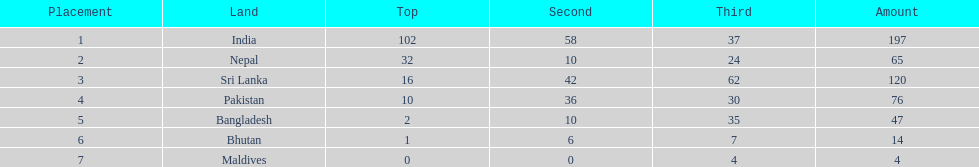How many gold medals were awarded between all 7 nations? 163. 